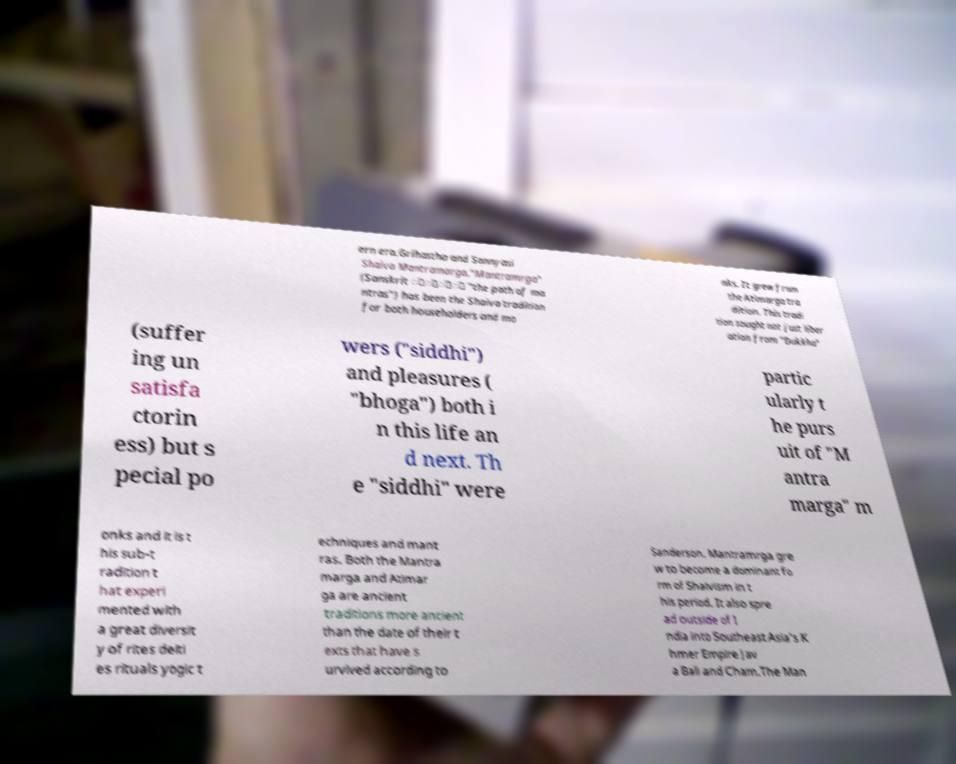What messages or text are displayed in this image? I need them in a readable, typed format. ern era.Grihastha and Sannyasi Shaiva Mantramarga."Mantramrga" (Sanskrit ््ा् "the path of ma ntras") has been the Shaiva tradition for both householders and mo nks. It grew from the Atimarga tra dition. This tradi tion sought not just liber ation from "Dukkha" (suffer ing un satisfa ctorin ess) but s pecial po wers ("siddhi") and pleasures ( "bhoga") both i n this life an d next. Th e "siddhi" were partic ularly t he purs uit of "M antra marga" m onks and it is t his sub-t radition t hat experi mented with a great diversit y of rites deiti es rituals yogic t echniques and mant ras. Both the Mantra marga and Atimar ga are ancient traditions more ancient than the date of their t exts that have s urvived according to Sanderson. Mantramrga gre w to become a dominant fo rm of Shaivism in t his period. It also spre ad outside of I ndia into Southeast Asia's K hmer Empire Jav a Bali and Cham.The Man 